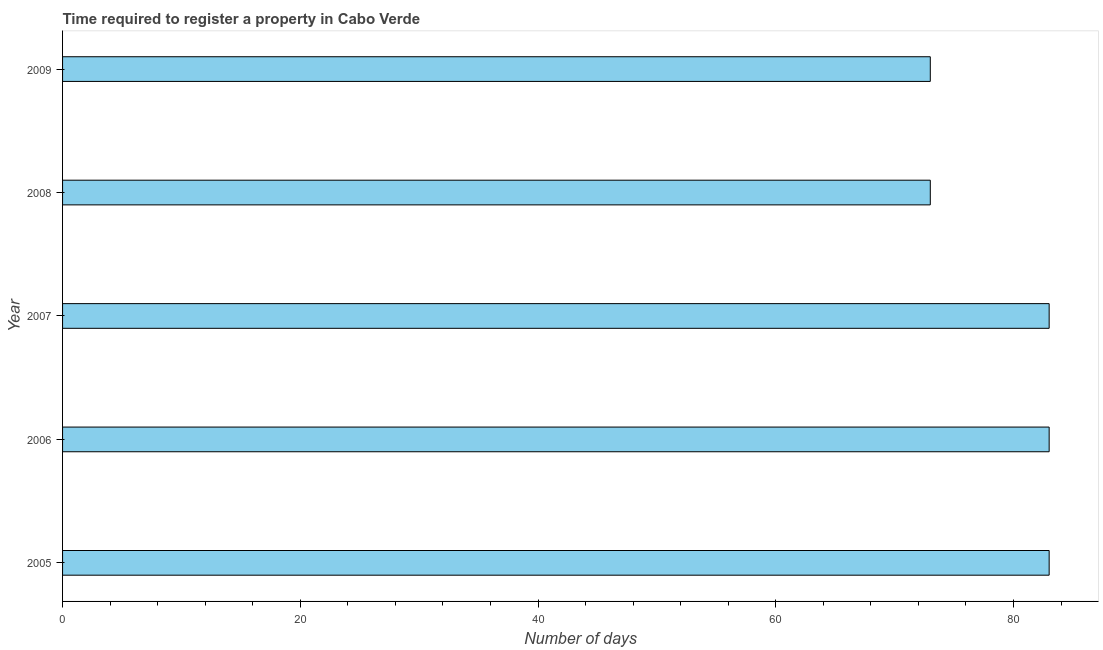Does the graph contain grids?
Provide a succinct answer. No. What is the title of the graph?
Keep it short and to the point. Time required to register a property in Cabo Verde. What is the label or title of the X-axis?
Your response must be concise. Number of days. Across all years, what is the minimum number of days required to register property?
Offer a very short reply. 73. In which year was the number of days required to register property maximum?
Give a very brief answer. 2005. In which year was the number of days required to register property minimum?
Your answer should be compact. 2008. What is the sum of the number of days required to register property?
Keep it short and to the point. 395. What is the difference between the number of days required to register property in 2006 and 2008?
Ensure brevity in your answer.  10. What is the average number of days required to register property per year?
Ensure brevity in your answer.  79. Do a majority of the years between 2009 and 2007 (inclusive) have number of days required to register property greater than 28 days?
Provide a short and direct response. Yes. Is the difference between the number of days required to register property in 2006 and 2008 greater than the difference between any two years?
Offer a very short reply. Yes. What is the difference between the highest and the second highest number of days required to register property?
Provide a succinct answer. 0. In how many years, is the number of days required to register property greater than the average number of days required to register property taken over all years?
Provide a short and direct response. 3. How many bars are there?
Make the answer very short. 5. Are all the bars in the graph horizontal?
Ensure brevity in your answer.  Yes. How many years are there in the graph?
Your response must be concise. 5. What is the difference between two consecutive major ticks on the X-axis?
Give a very brief answer. 20. Are the values on the major ticks of X-axis written in scientific E-notation?
Your response must be concise. No. What is the Number of days of 2005?
Provide a short and direct response. 83. What is the Number of days of 2007?
Your response must be concise. 83. What is the Number of days in 2008?
Offer a very short reply. 73. What is the Number of days in 2009?
Provide a short and direct response. 73. What is the difference between the Number of days in 2005 and 2007?
Your response must be concise. 0. What is the difference between the Number of days in 2005 and 2009?
Provide a short and direct response. 10. What is the difference between the Number of days in 2006 and 2007?
Provide a short and direct response. 0. What is the difference between the Number of days in 2008 and 2009?
Offer a terse response. 0. What is the ratio of the Number of days in 2005 to that in 2006?
Ensure brevity in your answer.  1. What is the ratio of the Number of days in 2005 to that in 2007?
Provide a short and direct response. 1. What is the ratio of the Number of days in 2005 to that in 2008?
Provide a succinct answer. 1.14. What is the ratio of the Number of days in 2005 to that in 2009?
Keep it short and to the point. 1.14. What is the ratio of the Number of days in 2006 to that in 2007?
Provide a short and direct response. 1. What is the ratio of the Number of days in 2006 to that in 2008?
Provide a short and direct response. 1.14. What is the ratio of the Number of days in 2006 to that in 2009?
Offer a very short reply. 1.14. What is the ratio of the Number of days in 2007 to that in 2008?
Ensure brevity in your answer.  1.14. What is the ratio of the Number of days in 2007 to that in 2009?
Ensure brevity in your answer.  1.14. What is the ratio of the Number of days in 2008 to that in 2009?
Make the answer very short. 1. 